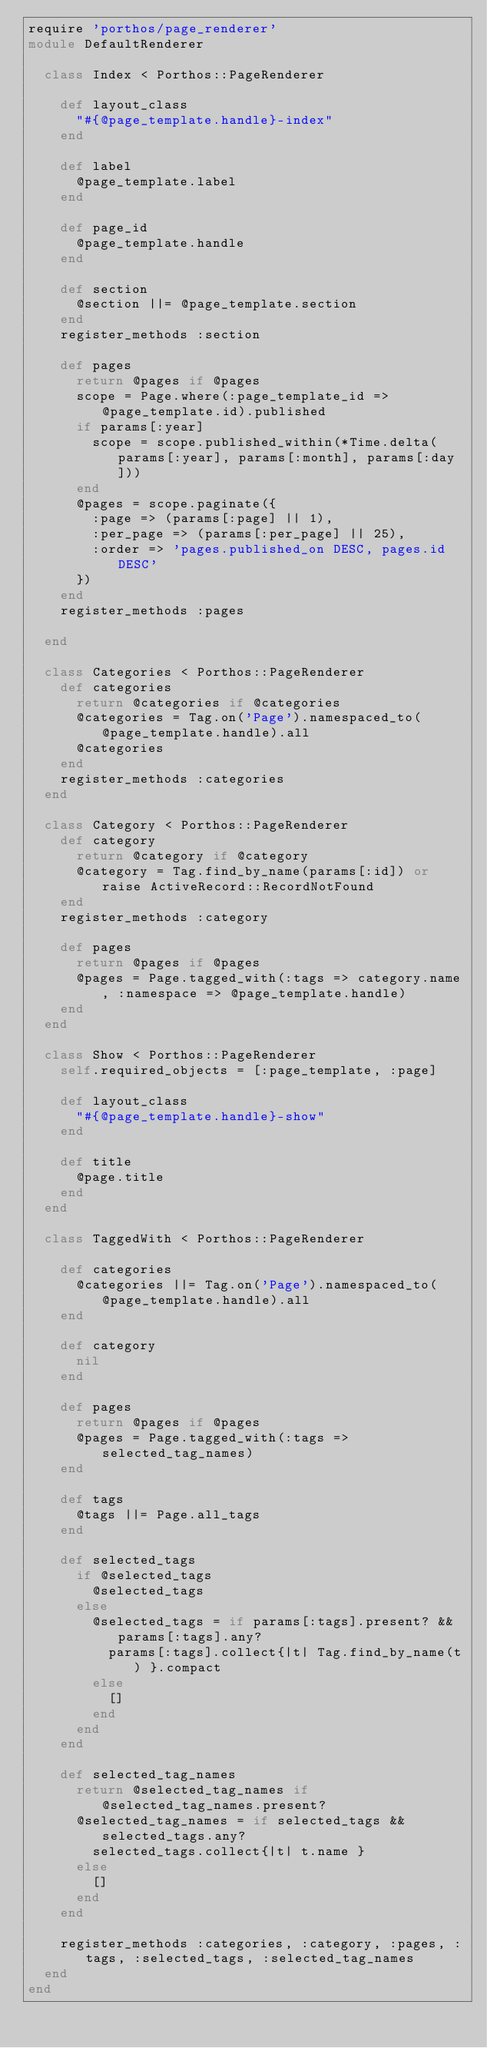Convert code to text. <code><loc_0><loc_0><loc_500><loc_500><_Ruby_>require 'porthos/page_renderer'
module DefaultRenderer

  class Index < Porthos::PageRenderer

    def layout_class
      "#{@page_template.handle}-index"
    end

    def label
      @page_template.label
    end

    def page_id
      @page_template.handle
    end

    def section
      @section ||= @page_template.section
    end
    register_methods :section

    def pages
      return @pages if @pages
      scope = Page.where(:page_template_id => @page_template.id).published
      if params[:year]
        scope = scope.published_within(*Time.delta(params[:year], params[:month], params[:day]))
      end
      @pages = scope.paginate({
        :page => (params[:page] || 1),
        :per_page => (params[:per_page] || 25),
        :order => 'pages.published_on DESC, pages.id DESC'
      })
    end
    register_methods :pages

  end

  class Categories < Porthos::PageRenderer
    def categories
      return @categories if @categories
      @categories = Tag.on('Page').namespaced_to(@page_template.handle).all
      @categories
    end
    register_methods :categories
  end

  class Category < Porthos::PageRenderer
    def category
      return @category if @category
      @category = Tag.find_by_name(params[:id]) or raise ActiveRecord::RecordNotFound
    end
    register_methods :category

    def pages
      return @pages if @pages
      @pages = Page.tagged_with(:tags => category.name, :namespace => @page_template.handle)
    end
  end

  class Show < Porthos::PageRenderer
    self.required_objects = [:page_template, :page]

    def layout_class
      "#{@page_template.handle}-show"
    end

    def title
      @page.title
    end
  end

  class TaggedWith < Porthos::PageRenderer

    def categories
      @categories ||= Tag.on('Page').namespaced_to(@page_template.handle).all
    end

    def category
      nil
    end

    def pages
      return @pages if @pages
      @pages = Page.tagged_with(:tags => selected_tag_names)
    end

    def tags
      @tags ||= Page.all_tags
    end

    def selected_tags
      if @selected_tags
        @selected_tags
      else
        @selected_tags = if params[:tags].present? && params[:tags].any?
          params[:tags].collect{|t| Tag.find_by_name(t) }.compact
        else
          []
        end
      end
    end

    def selected_tag_names
      return @selected_tag_names if @selected_tag_names.present?
      @selected_tag_names = if selected_tags && selected_tags.any?
        selected_tags.collect{|t| t.name }
      else
        []
      end
    end

    register_methods :categories, :category, :pages, :tags, :selected_tags, :selected_tag_names
  end
end
</code> 